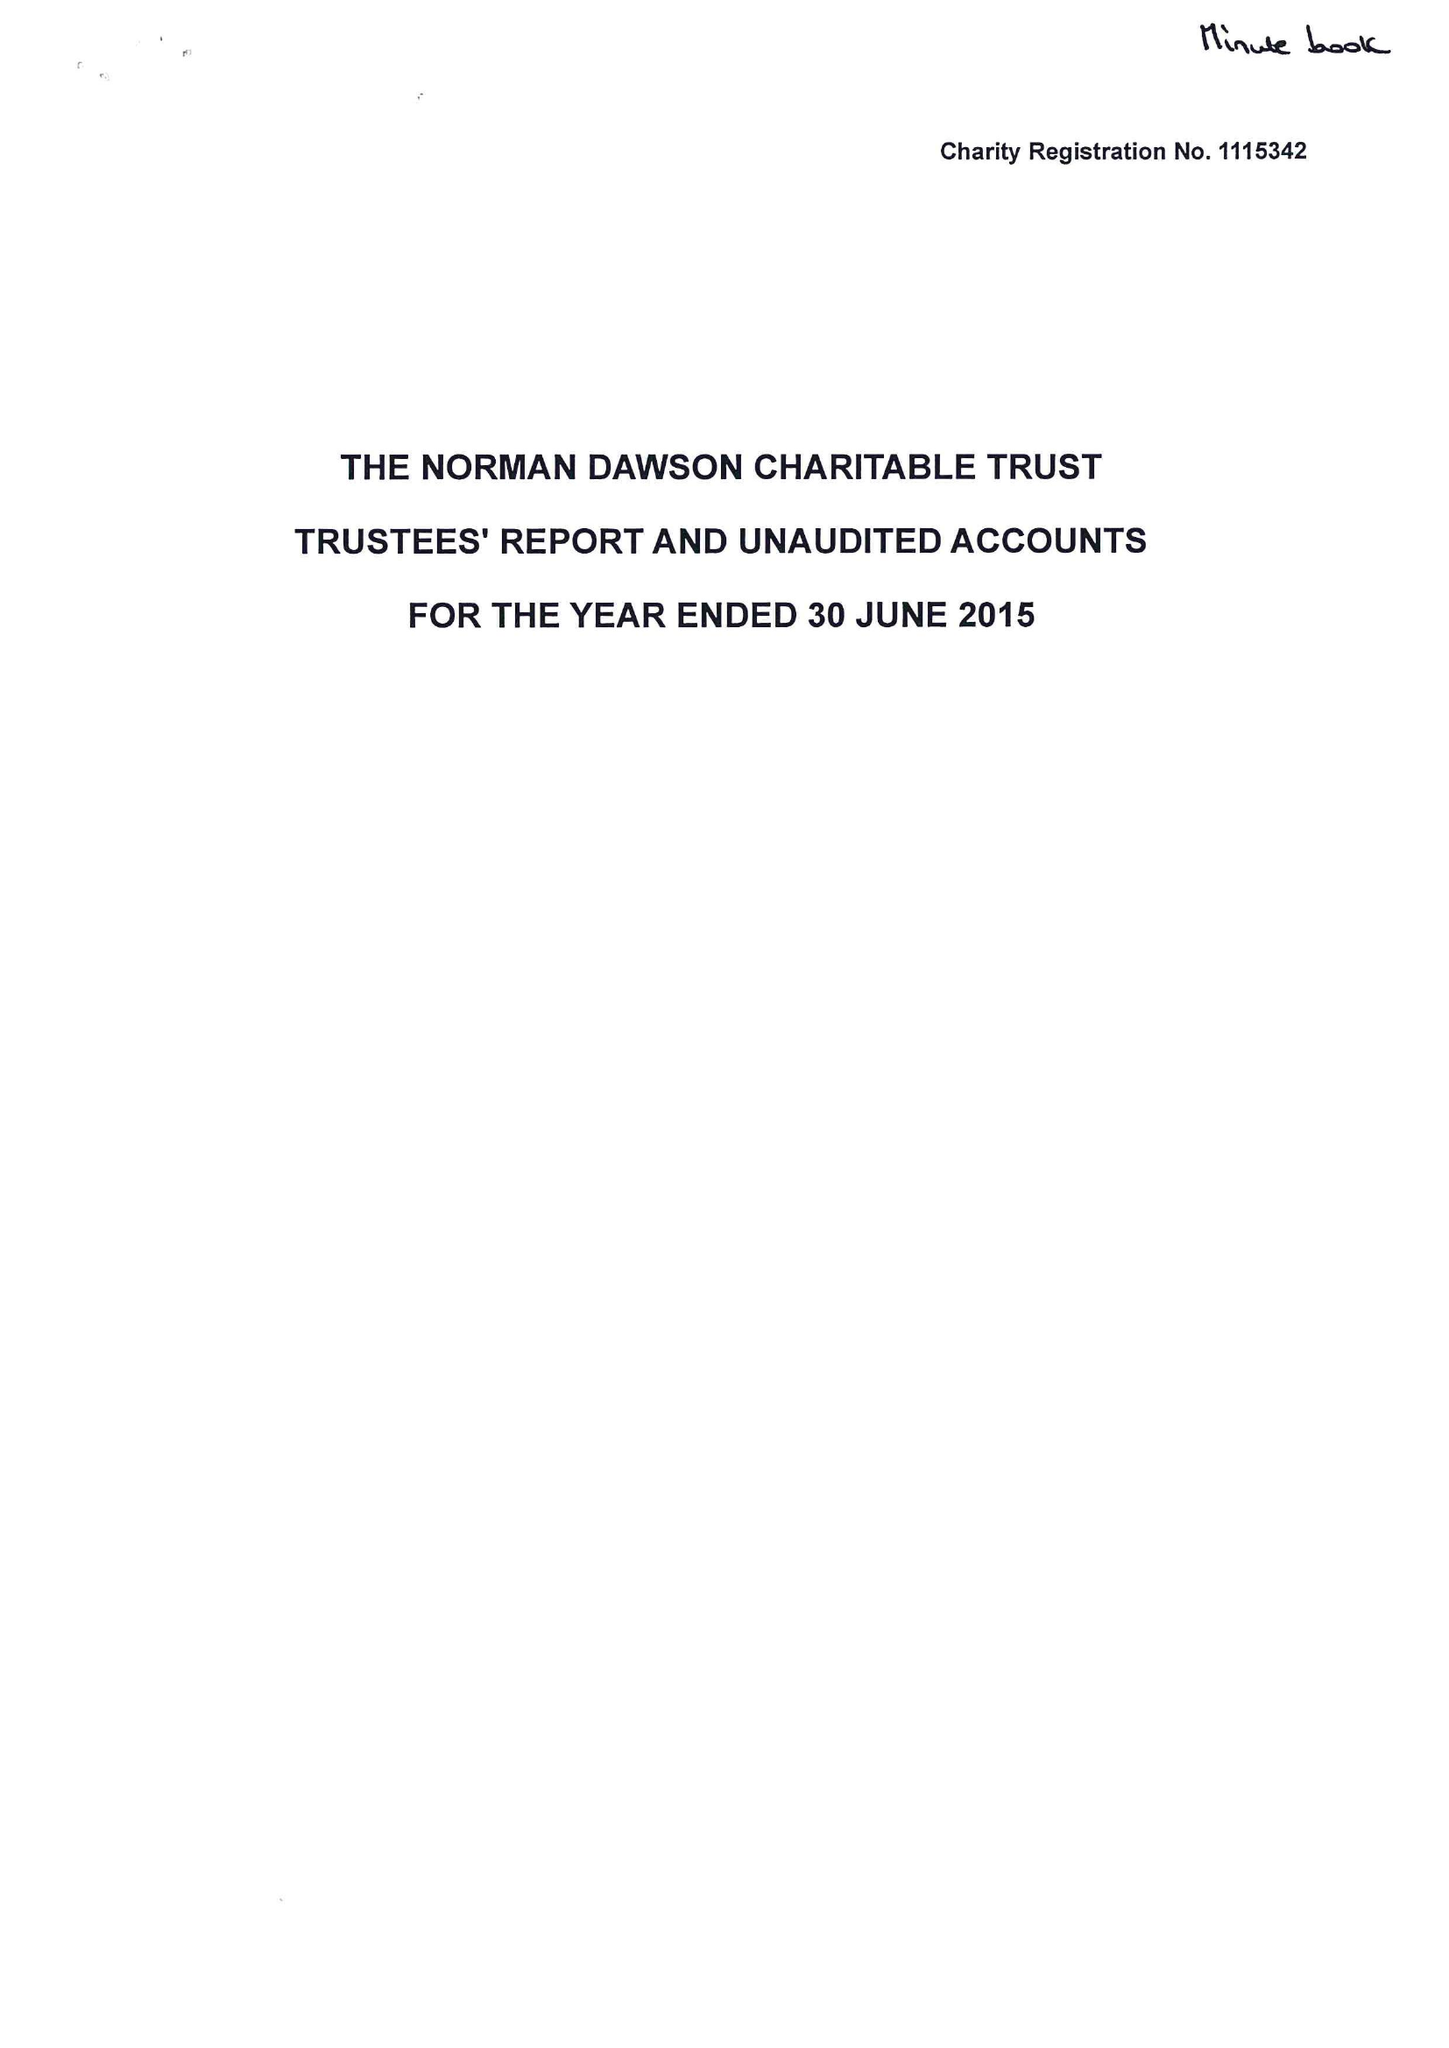What is the value for the address__street_line?
Answer the question using a single word or phrase. BIRMINGHAM ROAD 